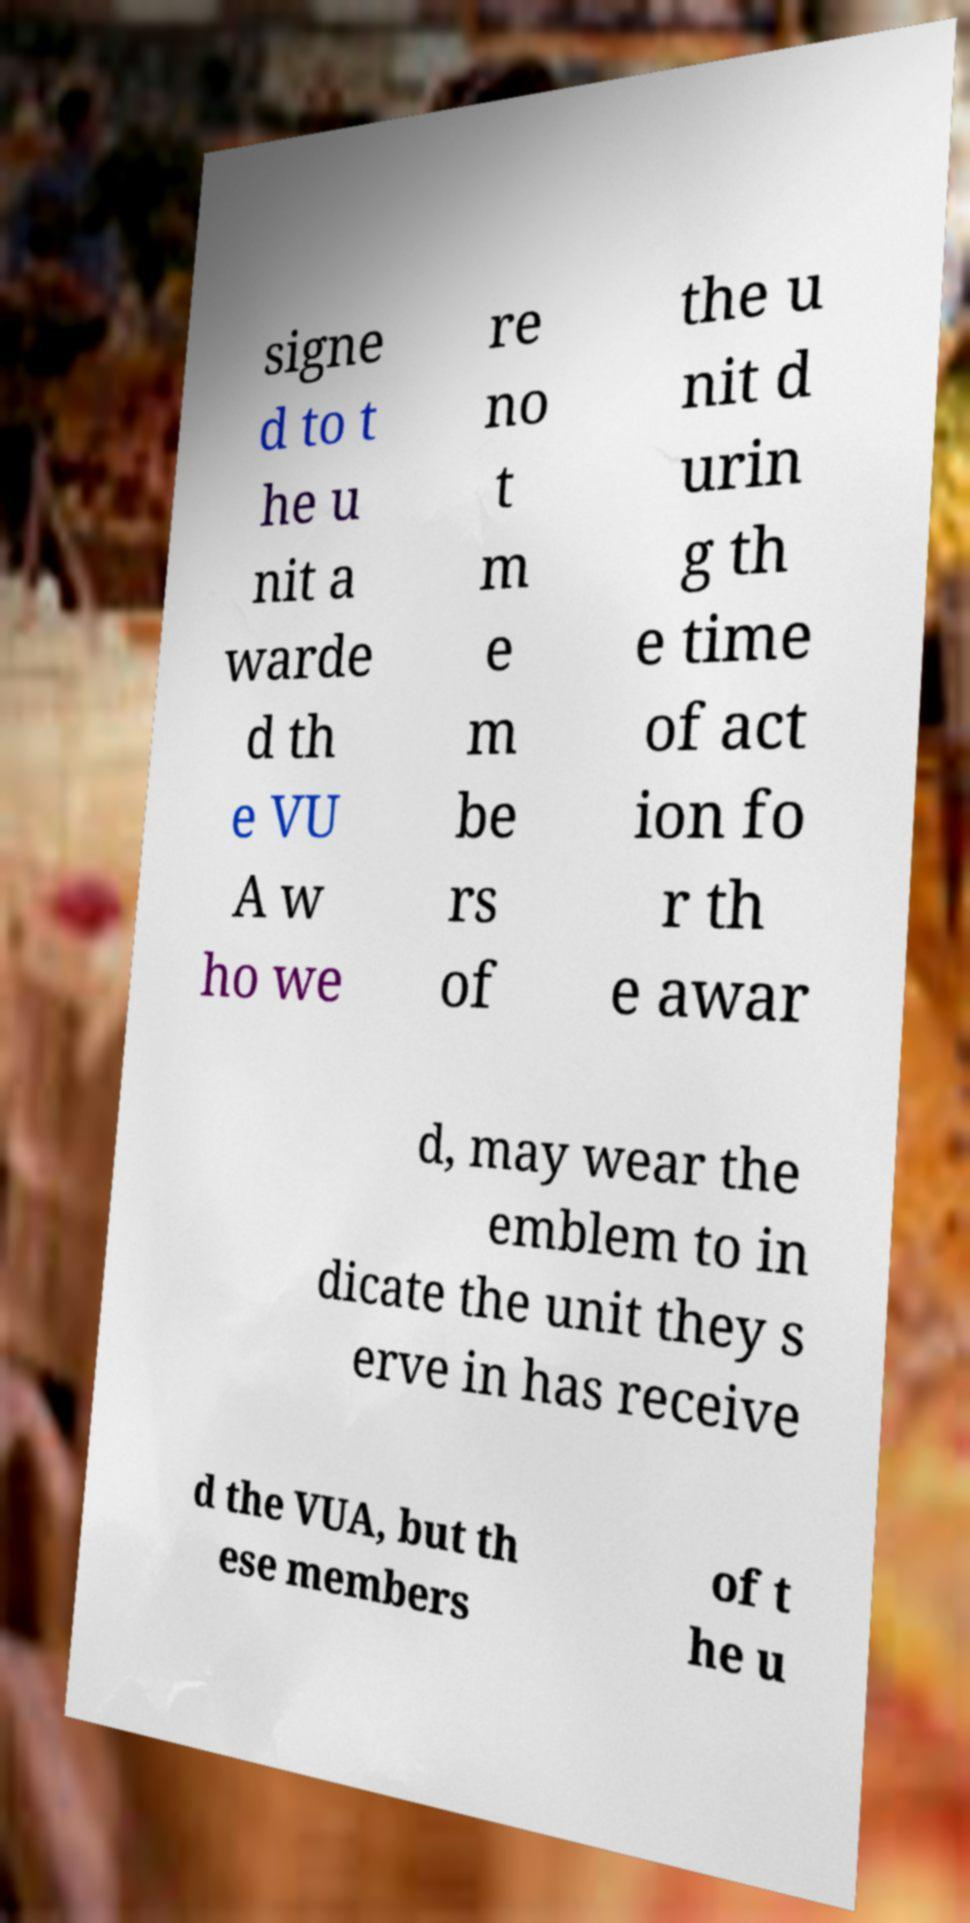There's text embedded in this image that I need extracted. Can you transcribe it verbatim? signe d to t he u nit a warde d th e VU A w ho we re no t m e m be rs of the u nit d urin g th e time of act ion fo r th e awar d, may wear the emblem to in dicate the unit they s erve in has receive d the VUA, but th ese members of t he u 